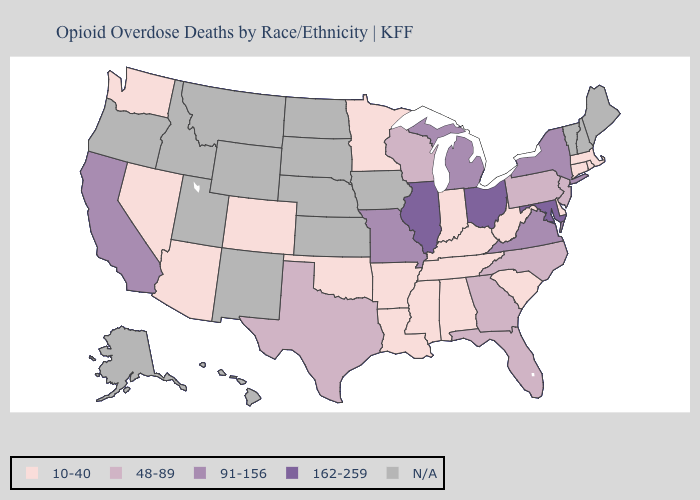Name the states that have a value in the range N/A?
Write a very short answer. Alaska, Hawaii, Idaho, Iowa, Kansas, Maine, Montana, Nebraska, New Hampshire, New Mexico, North Dakota, Oregon, South Dakota, Utah, Vermont, Wyoming. Does the map have missing data?
Answer briefly. Yes. Among the states that border Massachusetts , which have the lowest value?
Give a very brief answer. Connecticut, Rhode Island. Which states hav the highest value in the South?
Give a very brief answer. Maryland. What is the value of Connecticut?
Answer briefly. 10-40. Is the legend a continuous bar?
Quick response, please. No. Name the states that have a value in the range 162-259?
Quick response, please. Illinois, Maryland, Ohio. Does Alabama have the lowest value in the USA?
Write a very short answer. Yes. Name the states that have a value in the range N/A?
Concise answer only. Alaska, Hawaii, Idaho, Iowa, Kansas, Maine, Montana, Nebraska, New Hampshire, New Mexico, North Dakota, Oregon, South Dakota, Utah, Vermont, Wyoming. Which states have the lowest value in the West?
Concise answer only. Arizona, Colorado, Nevada, Washington. What is the lowest value in states that border Alabama?
Answer briefly. 10-40. Name the states that have a value in the range N/A?
Give a very brief answer. Alaska, Hawaii, Idaho, Iowa, Kansas, Maine, Montana, Nebraska, New Hampshire, New Mexico, North Dakota, Oregon, South Dakota, Utah, Vermont, Wyoming. Does the first symbol in the legend represent the smallest category?
Short answer required. Yes. 